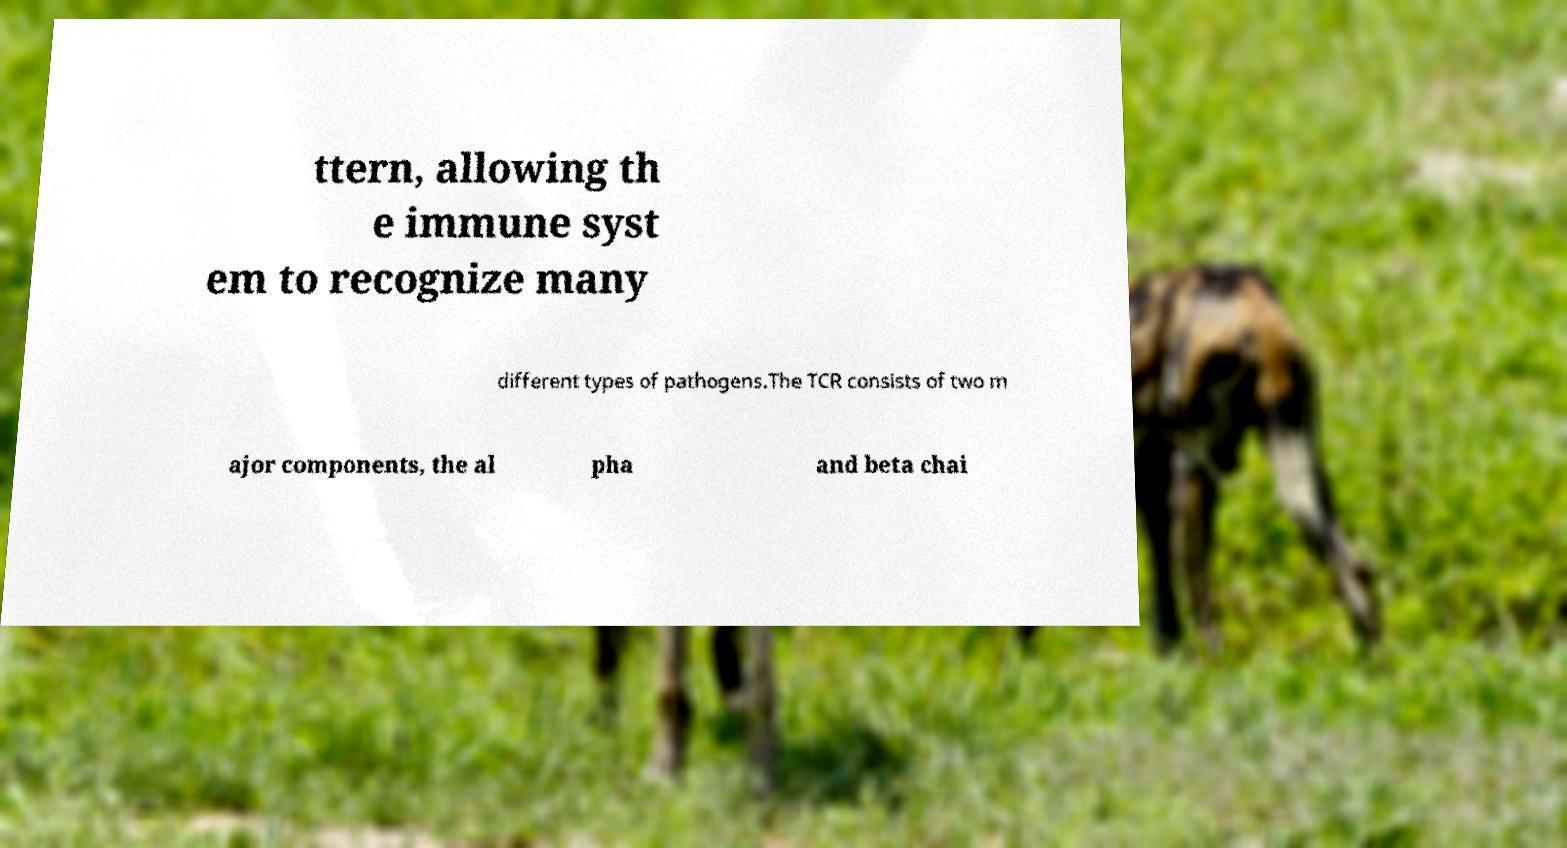I need the written content from this picture converted into text. Can you do that? ttern, allowing th e immune syst em to recognize many different types of pathogens.The TCR consists of two m ajor components, the al pha and beta chai 